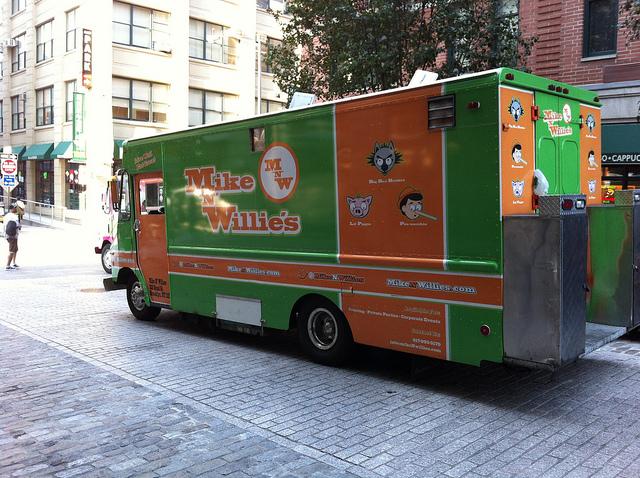What color is the truck?
Give a very brief answer. Green and orange. What is in the truck?
Answer briefly. Food. What is this vehicle for?
Give a very brief answer. Food. 